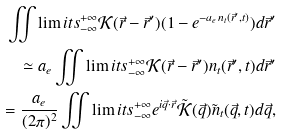<formula> <loc_0><loc_0><loc_500><loc_500>\iint \lim i t s _ { - \infty } ^ { + \infty } \mathcal { K } ( \vec { r } - \vec { r } ^ { \prime } ) ( 1 - e ^ { - a _ { e } n _ { t } ( \vec { r } ^ { \prime } , t ) } ) d \vec { r } ^ { \prime } \\ \simeq a _ { e } \iint \lim i t s _ { - \infty } ^ { + \infty } \mathcal { K } ( \vec { r } - \vec { r } ^ { \prime } ) n _ { t } ( \vec { r } ^ { \prime } , t ) d \vec { r } ^ { \prime } \\ = \frac { a _ { e } } { ( 2 \pi ) ^ { 2 } } \iint \lim i t s _ { - \infty } ^ { + \infty } e ^ { i \vec { q } \cdot \vec { r } } \tilde { \mathcal { K } } ( \vec { q } ) \tilde { n } _ { t } ( \vec { q } , t ) d \vec { q } ,</formula> 